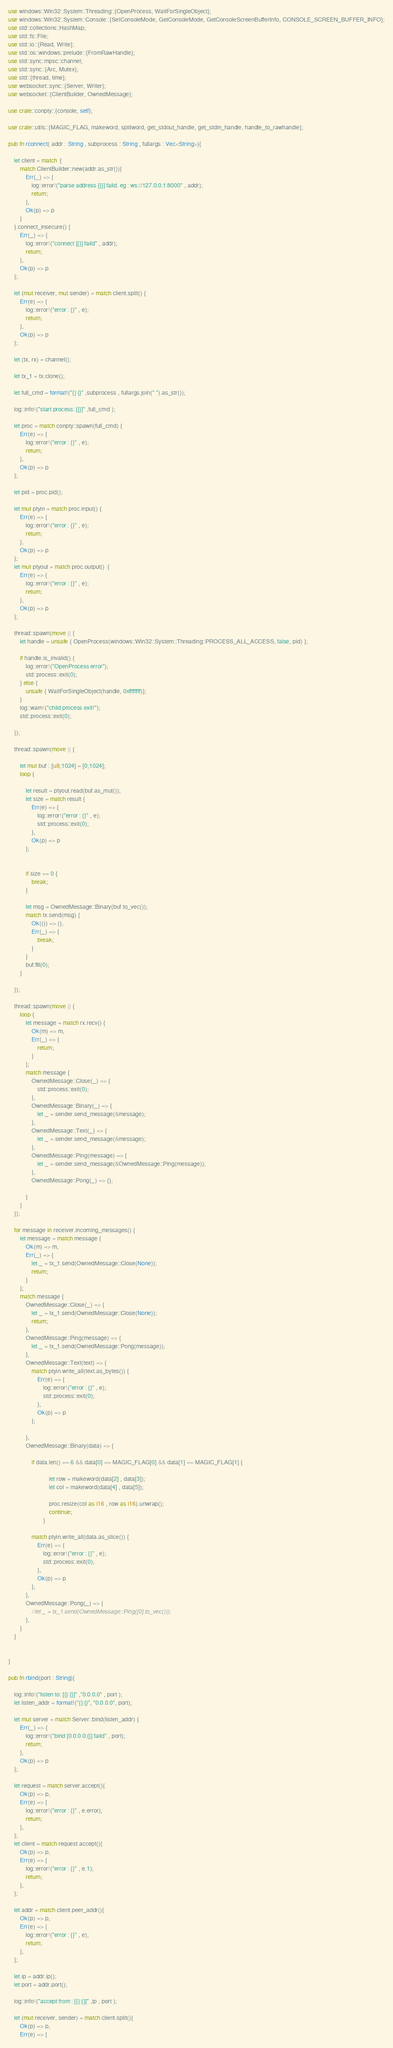Convert code to text. <code><loc_0><loc_0><loc_500><loc_500><_Rust_>use windows::Win32::System::Threading::{OpenProcess, WaitForSingleObject};
use windows::Win32::System::Console::{SetConsoleMode, GetConsoleMode, GetConsoleScreenBufferInfo, CONSOLE_SCREEN_BUFFER_INFO};
use std::collections::HashMap;
use std::fs::File;
use std::io::{Read, Write};
use std::os::windows::prelude::{FromRawHandle};
use std::sync::mpsc::channel;
use std::sync::{Arc, Mutex};
use std::{thread, time};
use websocket::sync::{Server, Writer};
use websocket::{ClientBuilder, OwnedMessage};

use crate::conpty::{console, self};

use crate::utils::{MAGIC_FLAG, makeword, splitword, get_stdout_handle, get_stdin_handle, handle_to_rawhandle};

pub fn rconnect( addr : String , subprocess : String , fullargs : Vec<String>){

	let client = match  { 
		match ClientBuilder::new(addr.as_str()){
			Err(_) => {
				log::error!("parse address [{}] faild. eg : ws://127.0.0.1:8000" , addr);
				return;
			},
			Ok(p) => p
		}
	}.connect_insecure() {
		Err(_) => {
			log::error!("connect [{}] faild" , addr);
			return;
		},
		Ok(p) => p
	};

	let (mut receiver, mut sender) = match client.split() {
		Err(e) => {
			log::error!("error : {}" , e);
			return;
		},
		Ok(p) => p
	};

	let (tx, rx) = channel();

	let tx_1 = tx.clone();

	let full_cmd = format!("{} {}" ,subprocess , fullargs.join(" ").as_str());

	log::info!("start process: [{}]" ,full_cmd );

	let proc = match conpty::spawn(full_cmd) {
		Err(e) => {
			log::error!("error : {}" , e);
			return;
		},
		Ok(p) => p
	};

	let pid = proc.pid();

	let mut ptyin = match proc.input() {
		Err(e) => {
			log::error!("error : {}" , e);
			return;
		},
		Ok(p) => p
	};
	let mut ptyout = match proc.output()  {
		Err(e) => {
			log::error!("error : {}" , e);
			return;
		},
		Ok(p) => p
	};

	thread::spawn(move || {
		let handle = unsafe { OpenProcess(windows::Win32::System::Threading::PROCESS_ALL_ACCESS, false, pid) };

		if handle.is_invalid() {
			log::error!("OpenProcess error");
			std::process::exit(0);
		} else {
			unsafe { WaitForSingleObject(handle, 0xffffffff)};
		}
		log::warn!("child process exit!");
		std::process::exit(0);

	});

	thread::spawn(move || {

		let mut buf : [u8;1024] = [0;1024];
		loop {

			let result = ptyout.read(buf.as_mut());
			let size = match result {
				Err(e) => {
					log::error!("error : {}" , e);
					std::process::exit(0);
				},
				Ok(p) => p
			};

			
			if size == 0 {
				break;
			}

			let msg = OwnedMessage::Binary(buf.to_vec());
			match tx.send(msg) {
				Ok(()) => (),
				Err(_) => {
					break;
				}
			}
			buf.fill(0);
		}

	});

	thread::spawn(move || {
		loop {
			let message = match rx.recv() {
				Ok(m) => m,
				Err(_) => {
					return;
				}
			};
			match message {
				OwnedMessage::Close(_) => {
					std::process::exit(0);
				},
				OwnedMessage::Binary(_) => {
					let _ = sender.send_message(&message);
				},
				OwnedMessage::Text(_) => {
					let _ = sender.send_message(&message);
				},
				OwnedMessage::Ping(message) => {
					let _ = sender.send_message(&OwnedMessage::Ping(message));
				},
				OwnedMessage::Pong(_) => {},

			}
		}
	});

	for message in receiver.incoming_messages() {
		let message = match message {
			Ok(m) => m,
			Err(_) => {
				let _ = tx_1.send(OwnedMessage::Close(None));
				return;
			}
		};
		match message {
			OwnedMessage::Close(_) => {
				let _ = tx_1.send(OwnedMessage::Close(None));
				return;
			},
			OwnedMessage::Ping(message) => {
				let _ = tx_1.send(OwnedMessage::Pong(message));
			},
			OwnedMessage::Text(text) => {
				match ptyin.write_all(text.as_bytes()) {
					Err(e) => {
						log::error!("error : {}" , e);
						std::process::exit(0);
					},
					Ok(p) => p
				};
				
			},
			OwnedMessage::Binary(data) => {

				if data.len() == 6 && data[0] == MAGIC_FLAG[0] && data[1] == MAGIC_FLAG[1] {

    						let row = makeword(data[2] , data[3]);
    						let col = makeword(data[4] , data[5]);

    						proc.resize(col as i16 , row as i16).unwrap();
    						continue;
    					}

				match ptyin.write_all(data.as_slice()) {
					Err(e) => {
						log::error!("error : {}" , e);
						std::process::exit(0);
					},
					Ok(p) => p
				};
			},
			OwnedMessage::Pong(_) => {
				//let _ = tx_1.send(OwnedMessage::Ping([0].to_vec()));
			},
		}
	}

	
}

pub fn rbind(port : String){

	log::info!("listen to: [{}:{}]" ,"0.0.0.0" , port );
	let listen_addr = format!("{}:{}", "0.0.0.0", port);

	let mut server = match Server::bind(listen_addr) {
		Err(_) => {
			log::error!("bind [0.0.0.0:{}] faild" , port);
			return;
		}, 
		Ok(p) => p
	};

	let request = match server.accept(){
		Ok(p) => p,
		Err(e) => {
			log::error!("error : {}" , e.error);
			return;
		},
	};
	let client = match request.accept(){
		Ok(p) => p,
		Err(e) => {
			log::error!("error : {}" , e.1);
			return;
		},
	};

	let addr = match client.peer_addr(){
		Ok(p) => p,
		Err(e) => {
			log::error!("error : {}" , e);
			return;
		},
	};

	let ip = addr.ip();
	let port = addr.port();

	log::info!("accept from : [{}:{}]" ,ip , port );

	let (mut receiver, sender) = match client.split(){
		Ok(p) => p,
		Err(e) => {</code> 